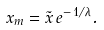<formula> <loc_0><loc_0><loc_500><loc_500>x _ { m } = \tilde { x } \, e ^ { - \, 1 / \lambda } .</formula> 